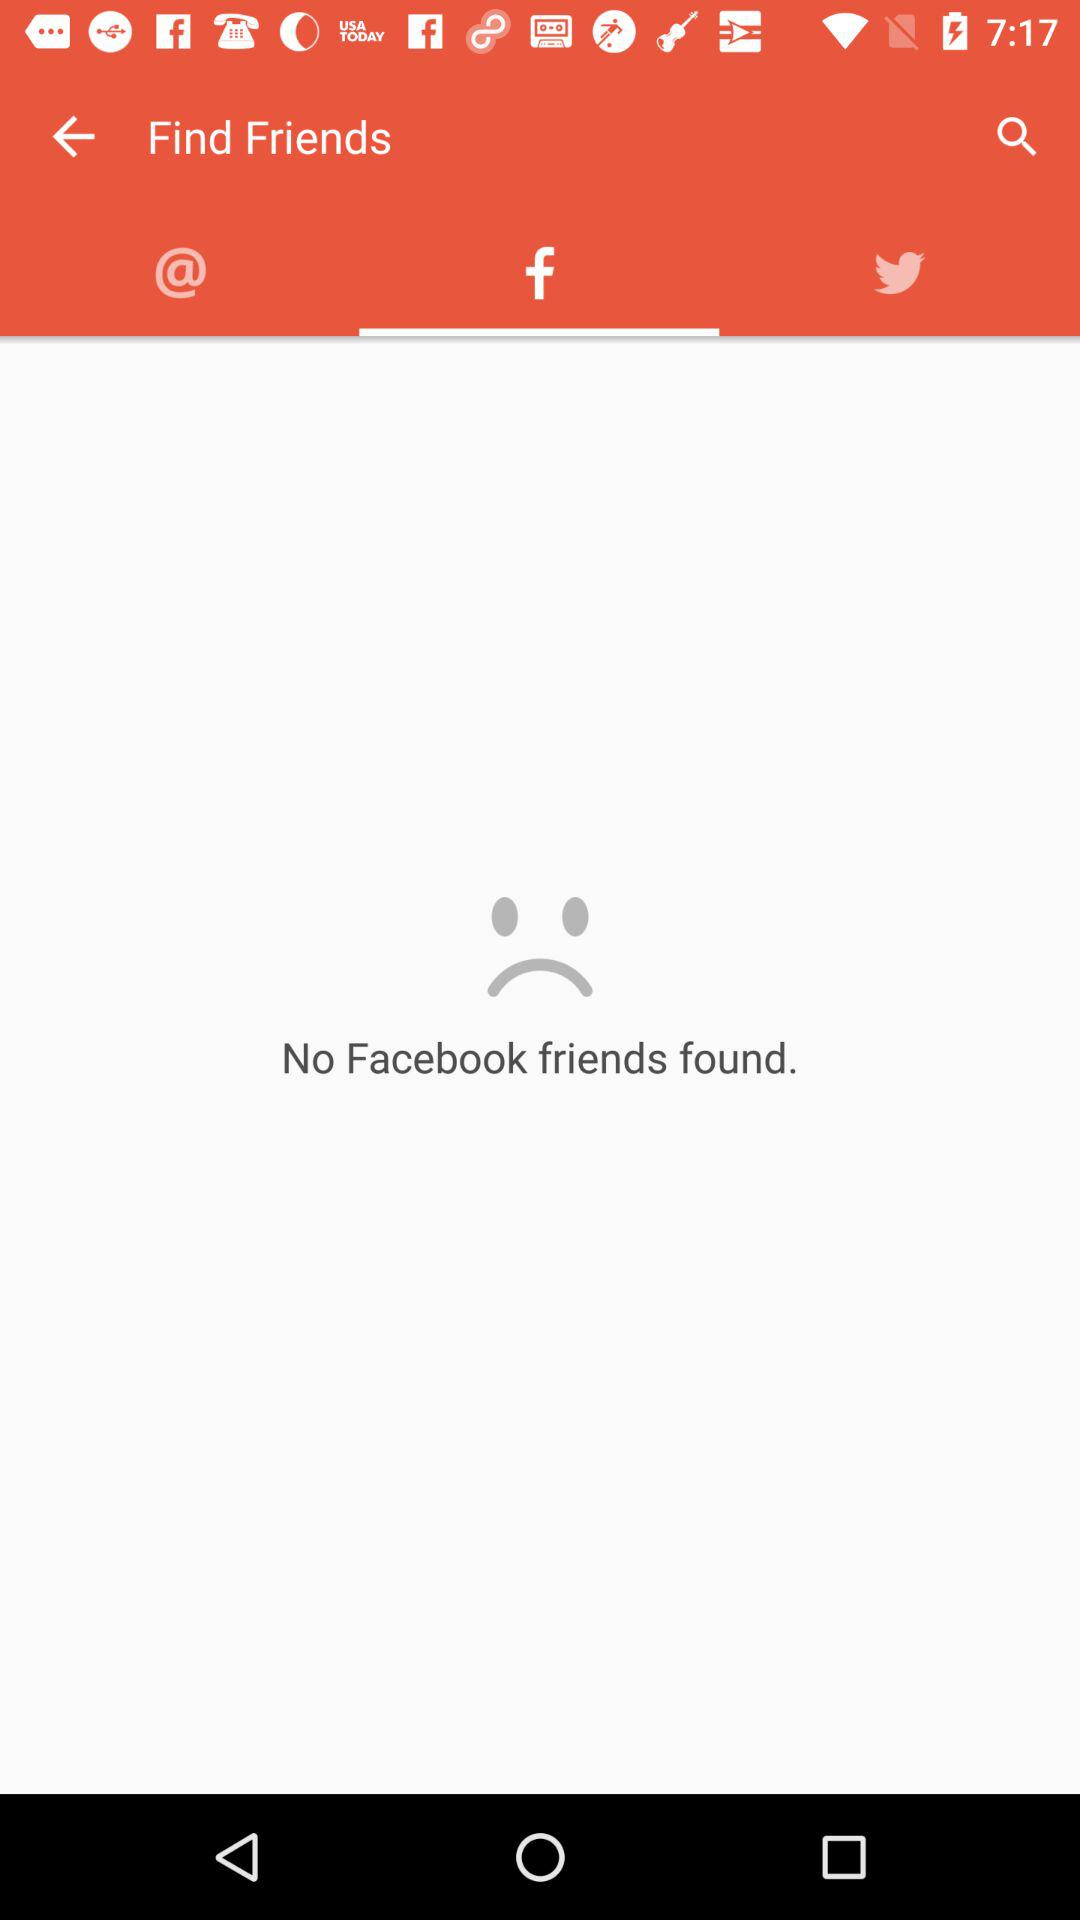Is there any "Facebook" friend? There is no "Facebook" friend. 